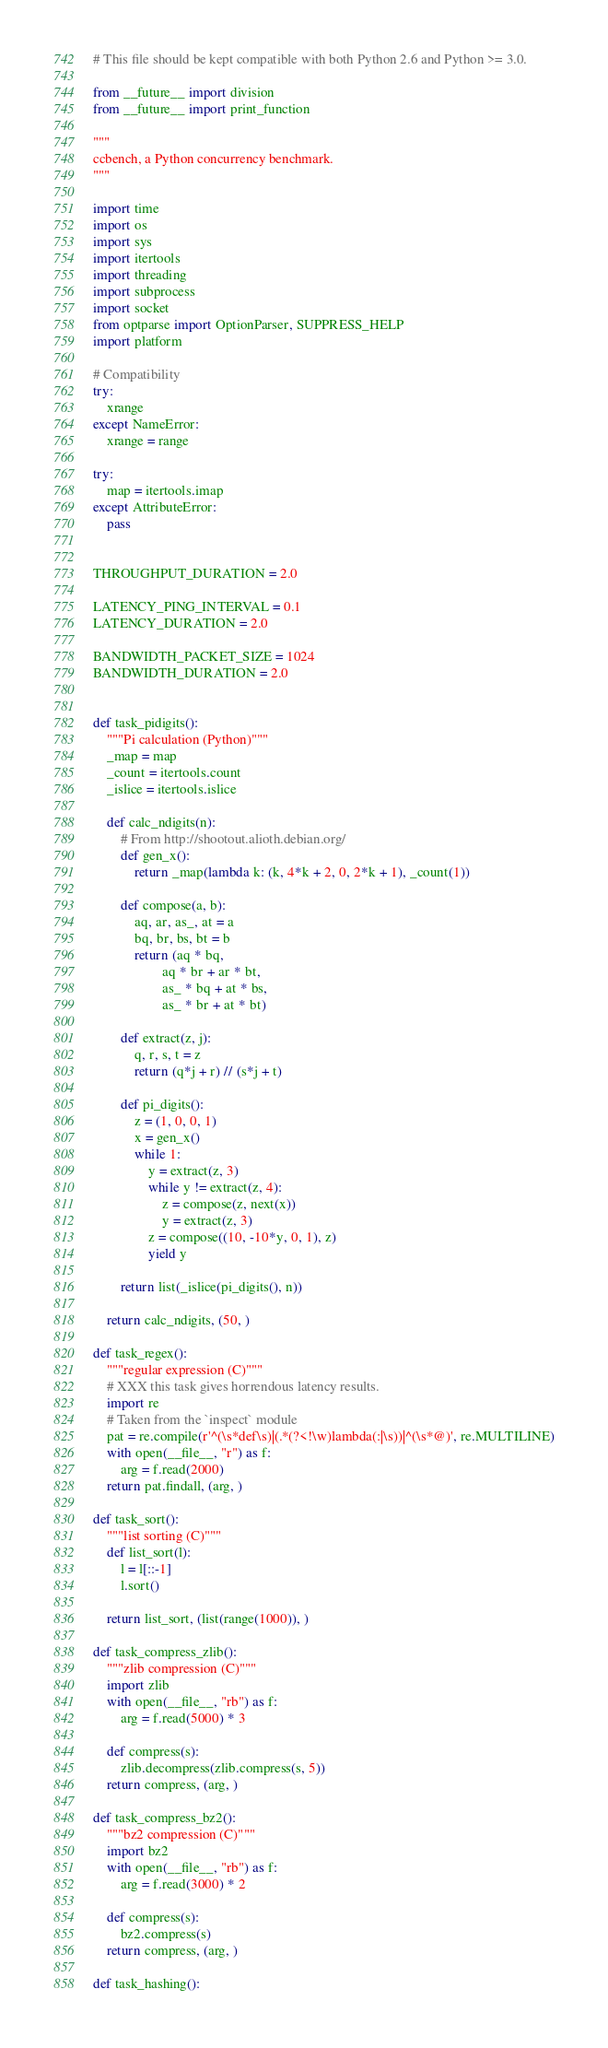Convert code to text. <code><loc_0><loc_0><loc_500><loc_500><_Python_># This file should be kept compatible with both Python 2.6 and Python >= 3.0.

from __future__ import division
from __future__ import print_function

"""
ccbench, a Python concurrency benchmark.
"""

import time
import os
import sys
import itertools
import threading
import subprocess
import socket
from optparse import OptionParser, SUPPRESS_HELP
import platform

# Compatibility
try:
    xrange
except NameError:
    xrange = range

try:
    map = itertools.imap
except AttributeError:
    pass


THROUGHPUT_DURATION = 2.0

LATENCY_PING_INTERVAL = 0.1
LATENCY_DURATION = 2.0

BANDWIDTH_PACKET_SIZE = 1024
BANDWIDTH_DURATION = 2.0


def task_pidigits():
    """Pi calculation (Python)"""
    _map = map
    _count = itertools.count
    _islice = itertools.islice

    def calc_ndigits(n):
        # From http://shootout.alioth.debian.org/
        def gen_x():
            return _map(lambda k: (k, 4*k + 2, 0, 2*k + 1), _count(1))

        def compose(a, b):
            aq, ar, as_, at = a
            bq, br, bs, bt = b
            return (aq * bq,
                    aq * br + ar * bt,
                    as_ * bq + at * bs,
                    as_ * br + at * bt)

        def extract(z, j):
            q, r, s, t = z
            return (q*j + r) // (s*j + t)

        def pi_digits():
            z = (1, 0, 0, 1)
            x = gen_x()
            while 1:
                y = extract(z, 3)
                while y != extract(z, 4):
                    z = compose(z, next(x))
                    y = extract(z, 3)
                z = compose((10, -10*y, 0, 1), z)
                yield y

        return list(_islice(pi_digits(), n))

    return calc_ndigits, (50, )

def task_regex():
    """regular expression (C)"""
    # XXX this task gives horrendous latency results.
    import re
    # Taken from the `inspect` module
    pat = re.compile(r'^(\s*def\s)|(.*(?<!\w)lambda(:|\s))|^(\s*@)', re.MULTILINE)
    with open(__file__, "r") as f:
        arg = f.read(2000)
    return pat.findall, (arg, )

def task_sort():
    """list sorting (C)"""
    def list_sort(l):
        l = l[::-1]
        l.sort()

    return list_sort, (list(range(1000)), )

def task_compress_zlib():
    """zlib compression (C)"""
    import zlib
    with open(__file__, "rb") as f:
        arg = f.read(5000) * 3

    def compress(s):
        zlib.decompress(zlib.compress(s, 5))
    return compress, (arg, )

def task_compress_bz2():
    """bz2 compression (C)"""
    import bz2
    with open(__file__, "rb") as f:
        arg = f.read(3000) * 2

    def compress(s):
        bz2.compress(s)
    return compress, (arg, )

def task_hashing():</code> 